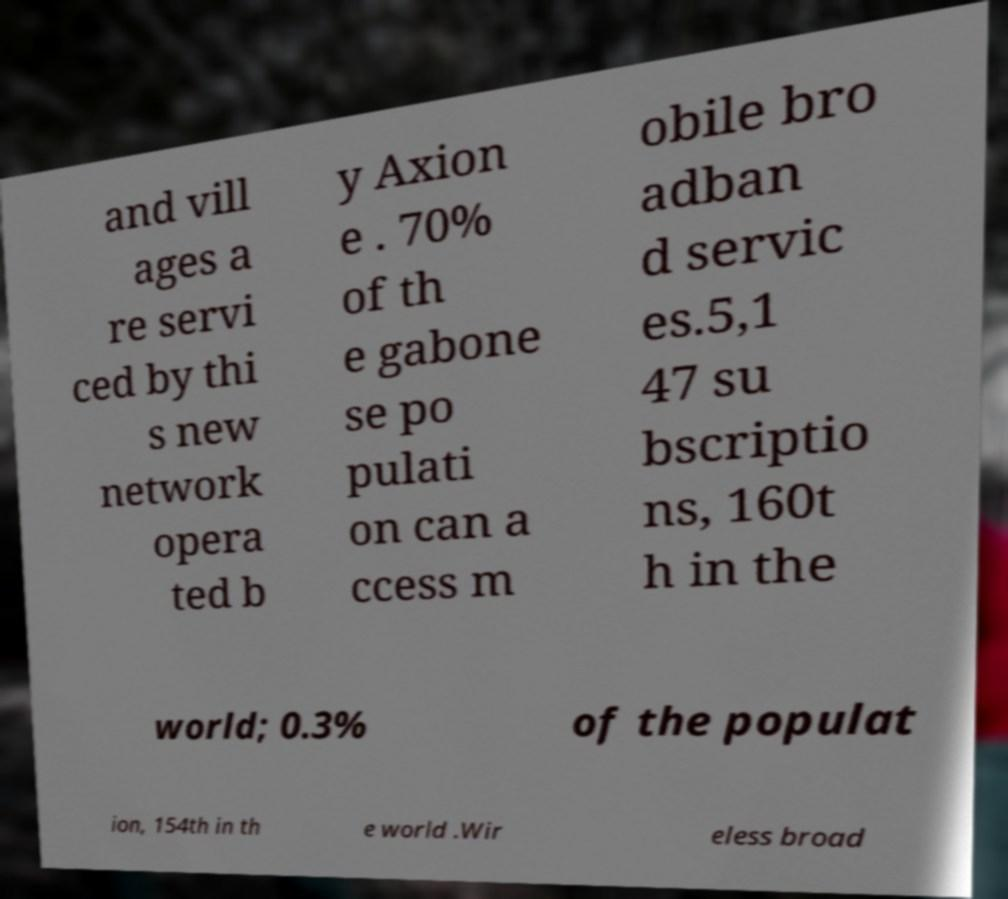Can you read and provide the text displayed in the image?This photo seems to have some interesting text. Can you extract and type it out for me? and vill ages a re servi ced by thi s new network opera ted b y Axion e . 70% of th e gabone se po pulati on can a ccess m obile bro adban d servic es.5,1 47 su bscriptio ns, 160t h in the world; 0.3% of the populat ion, 154th in th e world .Wir eless broad 